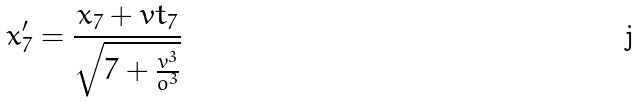Convert formula to latex. <formula><loc_0><loc_0><loc_500><loc_500>x _ { 7 } ^ { \prime } = \frac { x _ { 7 } + v t _ { 7 } } { \sqrt { 7 + \frac { v ^ { 3 } } { o ^ { 3 } } } }</formula> 